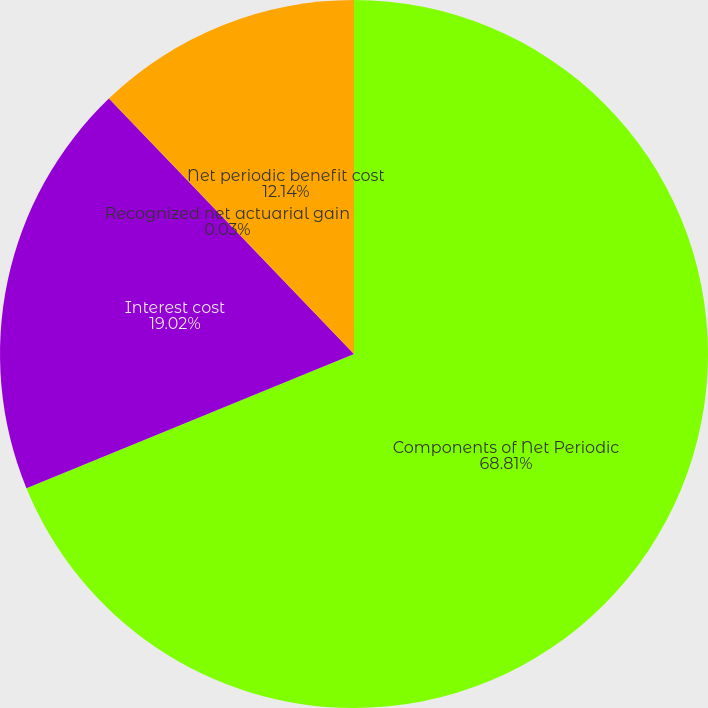<chart> <loc_0><loc_0><loc_500><loc_500><pie_chart><fcel>Components of Net Periodic<fcel>Interest cost<fcel>Recognized net actuarial gain<fcel>Net periodic benefit cost<nl><fcel>68.8%<fcel>19.02%<fcel>0.03%<fcel>12.14%<nl></chart> 